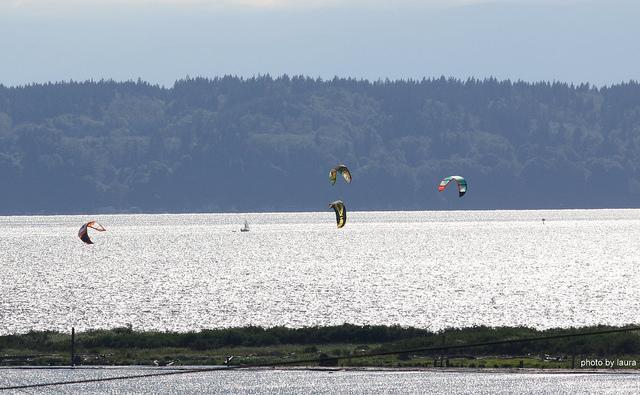How many bottles of beer are there?
Give a very brief answer. 0. 